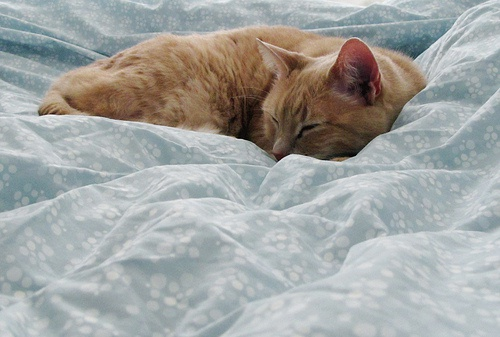Describe the objects in this image and their specific colors. I can see bed in darkgray and lightgray tones and cat in darkgray, gray, maroon, and tan tones in this image. 